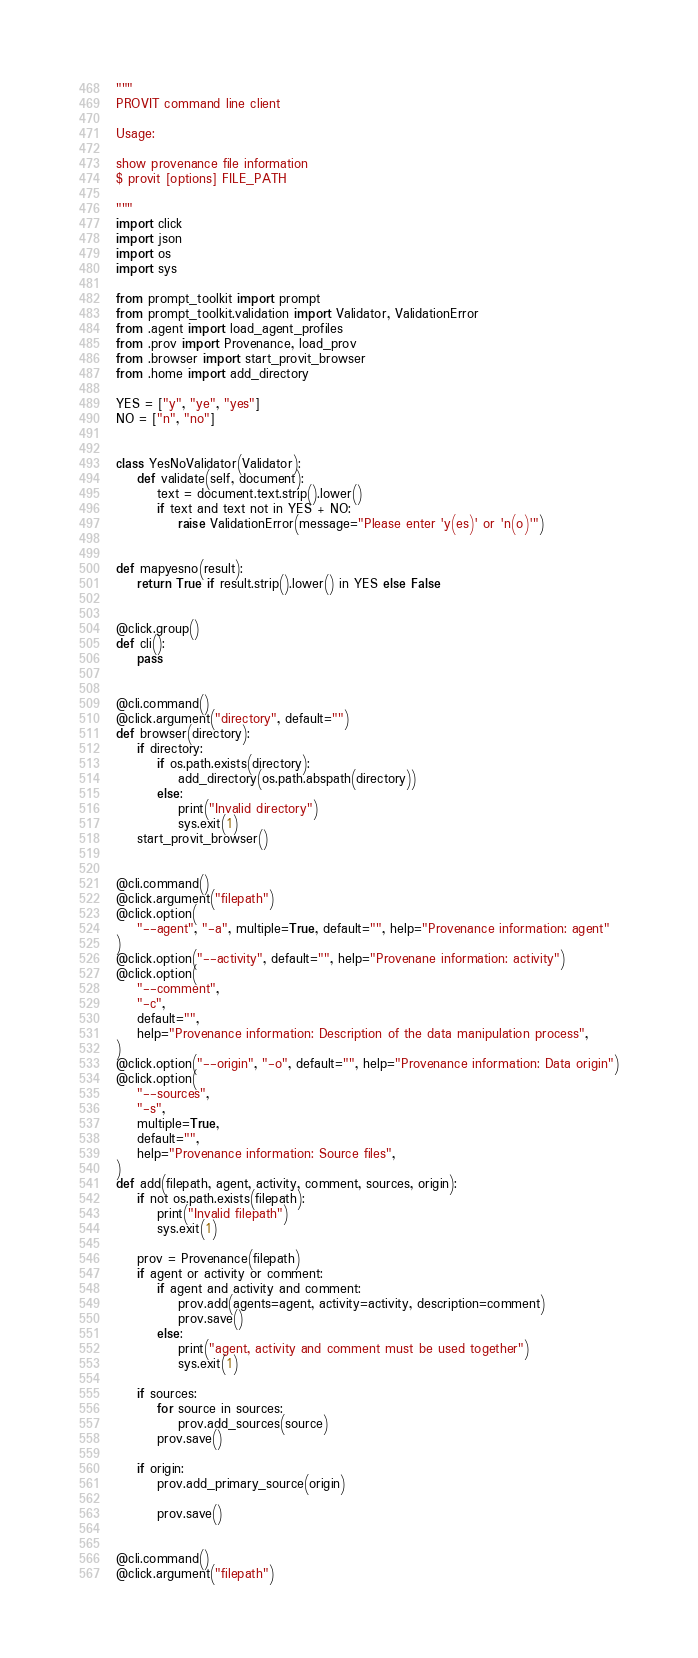<code> <loc_0><loc_0><loc_500><loc_500><_Python_>"""
PROVIT command line client

Usage:

show provenance file information
$ provit [options] FILE_PATH

"""
import click
import json
import os
import sys

from prompt_toolkit import prompt
from prompt_toolkit.validation import Validator, ValidationError
from .agent import load_agent_profiles
from .prov import Provenance, load_prov
from .browser import start_provit_browser
from .home import add_directory

YES = ["y", "ye", "yes"]
NO = ["n", "no"]


class YesNoValidator(Validator):
    def validate(self, document):
        text = document.text.strip().lower()
        if text and text not in YES + NO:
            raise ValidationError(message="Please enter 'y(es)' or 'n(o)'")


def mapyesno(result):
    return True if result.strip().lower() in YES else False


@click.group()
def cli():
    pass


@cli.command()
@click.argument("directory", default="")
def browser(directory):
    if directory:
        if os.path.exists(directory):
            add_directory(os.path.abspath(directory))
        else:
            print("Invalid directory")
            sys.exit(1)
    start_provit_browser()


@cli.command()
@click.argument("filepath")
@click.option(
    "--agent", "-a", multiple=True, default="", help="Provenance information: agent"
)
@click.option("--activity", default="", help="Provenane information: activity")
@click.option(
    "--comment",
    "-c",
    default="",
    help="Provenance information: Description of the data manipulation process",
)
@click.option("--origin", "-o", default="", help="Provenance information: Data origin")
@click.option(
    "--sources",
    "-s",
    multiple=True,
    default="",
    help="Provenance information: Source files",
)
def add(filepath, agent, activity, comment, sources, origin):
    if not os.path.exists(filepath):
        print("Invalid filepath")
        sys.exit(1)

    prov = Provenance(filepath)
    if agent or activity or comment:
        if agent and activity and comment:
            prov.add(agents=agent, activity=activity, description=comment)
            prov.save()
        else:
            print("agent, activity and comment must be used together")
            sys.exit(1)

    if sources:
        for source in sources:
            prov.add_sources(source)
        prov.save()

    if origin:
        prov.add_primary_source(origin)

        prov.save()


@cli.command()
@click.argument("filepath")</code> 